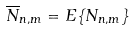<formula> <loc_0><loc_0><loc_500><loc_500>\overline { N } _ { n , m } = E \{ N _ { n , m } \}</formula> 